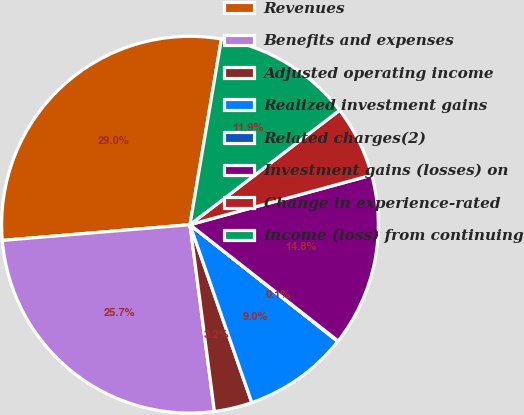Convert chart to OTSL. <chart><loc_0><loc_0><loc_500><loc_500><pie_chart><fcel>Revenues<fcel>Benefits and expenses<fcel>Adjusted operating income<fcel>Realized investment gains<fcel>Related charges(2)<fcel>Investment gains (losses) on<fcel>Change in experience-rated<fcel>Income (loss) from continuing<nl><fcel>29.0%<fcel>25.74%<fcel>3.25%<fcel>9.04%<fcel>0.05%<fcel>14.83%<fcel>6.15%<fcel>11.94%<nl></chart> 